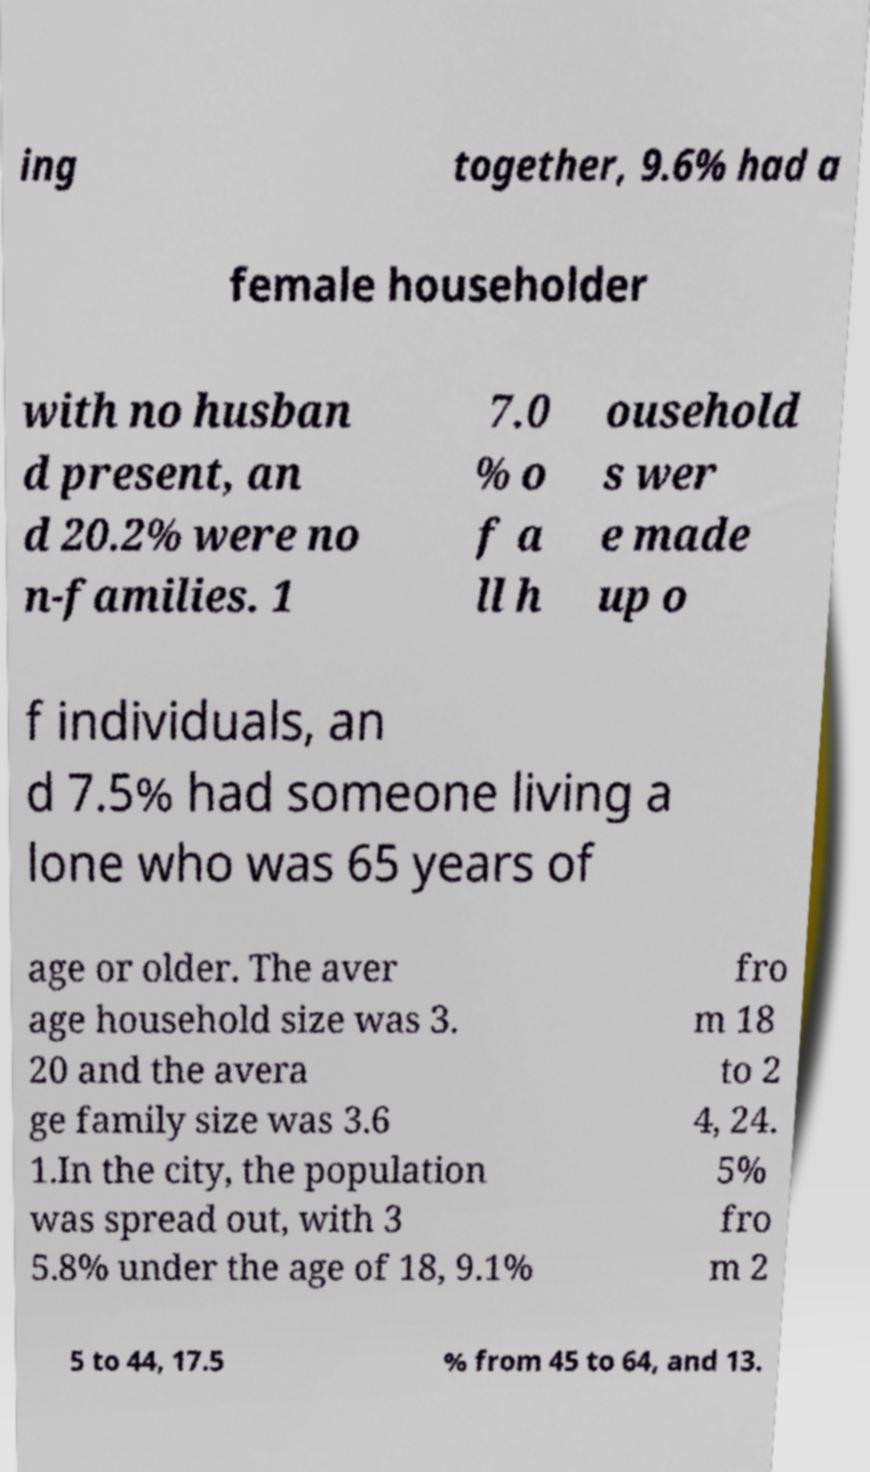For documentation purposes, I need the text within this image transcribed. Could you provide that? ing together, 9.6% had a female householder with no husban d present, an d 20.2% were no n-families. 1 7.0 % o f a ll h ousehold s wer e made up o f individuals, an d 7.5% had someone living a lone who was 65 years of age or older. The aver age household size was 3. 20 and the avera ge family size was 3.6 1.In the city, the population was spread out, with 3 5.8% under the age of 18, 9.1% fro m 18 to 2 4, 24. 5% fro m 2 5 to 44, 17.5 % from 45 to 64, and 13. 